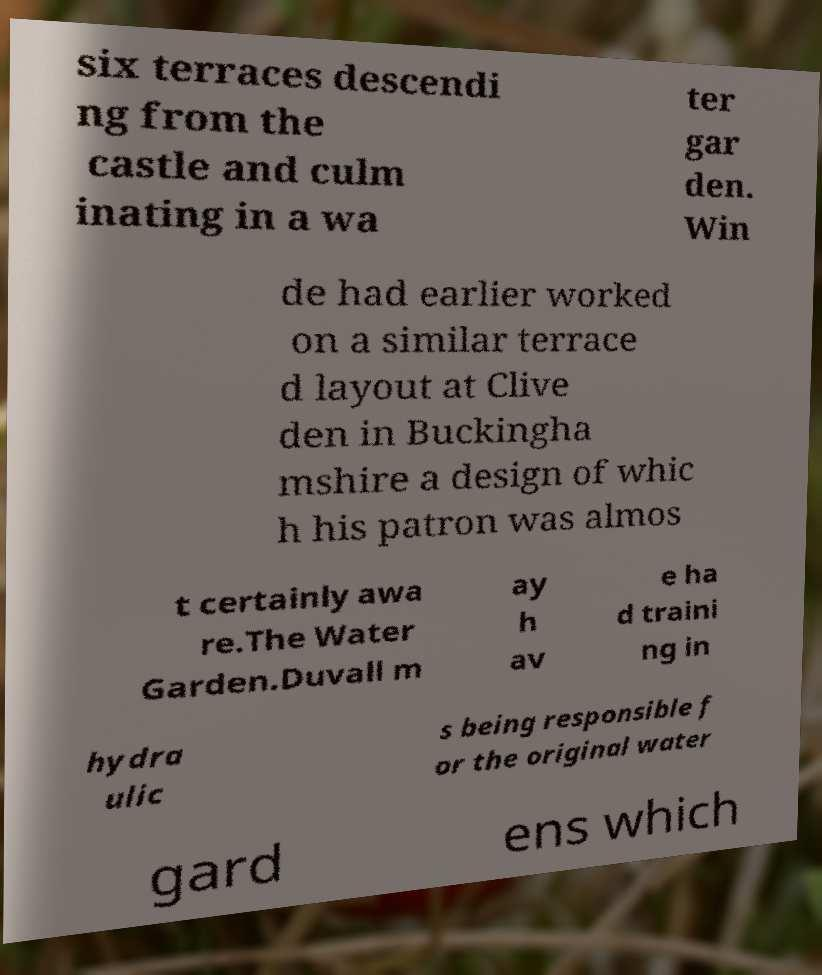For documentation purposes, I need the text within this image transcribed. Could you provide that? six terraces descendi ng from the castle and culm inating in a wa ter gar den. Win de had earlier worked on a similar terrace d layout at Clive den in Buckingha mshire a design of whic h his patron was almos t certainly awa re.The Water Garden.Duvall m ay h av e ha d traini ng in hydra ulic s being responsible f or the original water gard ens which 